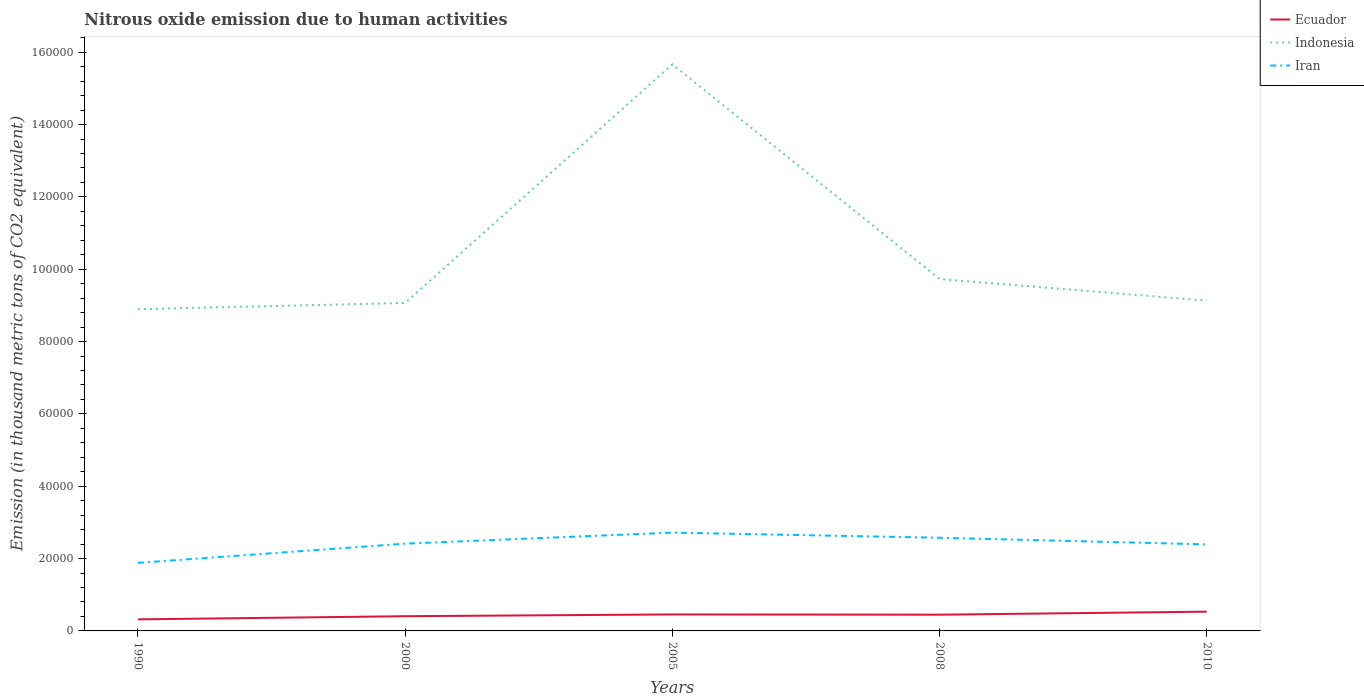How many different coloured lines are there?
Ensure brevity in your answer.  3. Across all years, what is the maximum amount of nitrous oxide emitted in Indonesia?
Your answer should be compact. 8.89e+04. What is the total amount of nitrous oxide emitted in Indonesia in the graph?
Provide a short and direct response. -6610.3. What is the difference between the highest and the second highest amount of nitrous oxide emitted in Ecuador?
Make the answer very short. 2134.1. How many lines are there?
Your answer should be very brief. 3. Does the graph contain grids?
Keep it short and to the point. No. What is the title of the graph?
Give a very brief answer. Nitrous oxide emission due to human activities. What is the label or title of the X-axis?
Offer a very short reply. Years. What is the label or title of the Y-axis?
Offer a terse response. Emission (in thousand metric tons of CO2 equivalent). What is the Emission (in thousand metric tons of CO2 equivalent) of Ecuador in 1990?
Your response must be concise. 3194. What is the Emission (in thousand metric tons of CO2 equivalent) of Indonesia in 1990?
Ensure brevity in your answer.  8.89e+04. What is the Emission (in thousand metric tons of CO2 equivalent) of Iran in 1990?
Provide a succinct answer. 1.88e+04. What is the Emission (in thousand metric tons of CO2 equivalent) of Ecuador in 2000?
Give a very brief answer. 4067.7. What is the Emission (in thousand metric tons of CO2 equivalent) of Indonesia in 2000?
Your answer should be very brief. 9.07e+04. What is the Emission (in thousand metric tons of CO2 equivalent) in Iran in 2000?
Your answer should be very brief. 2.41e+04. What is the Emission (in thousand metric tons of CO2 equivalent) in Ecuador in 2005?
Give a very brief answer. 4558.5. What is the Emission (in thousand metric tons of CO2 equivalent) in Indonesia in 2005?
Make the answer very short. 1.57e+05. What is the Emission (in thousand metric tons of CO2 equivalent) of Iran in 2005?
Offer a very short reply. 2.72e+04. What is the Emission (in thousand metric tons of CO2 equivalent) in Ecuador in 2008?
Give a very brief answer. 4488.1. What is the Emission (in thousand metric tons of CO2 equivalent) of Indonesia in 2008?
Your answer should be compact. 9.73e+04. What is the Emission (in thousand metric tons of CO2 equivalent) in Iran in 2008?
Provide a short and direct response. 2.58e+04. What is the Emission (in thousand metric tons of CO2 equivalent) in Ecuador in 2010?
Offer a terse response. 5328.1. What is the Emission (in thousand metric tons of CO2 equivalent) of Indonesia in 2010?
Ensure brevity in your answer.  9.13e+04. What is the Emission (in thousand metric tons of CO2 equivalent) in Iran in 2010?
Offer a terse response. 2.39e+04. Across all years, what is the maximum Emission (in thousand metric tons of CO2 equivalent) of Ecuador?
Ensure brevity in your answer.  5328.1. Across all years, what is the maximum Emission (in thousand metric tons of CO2 equivalent) of Indonesia?
Provide a succinct answer. 1.57e+05. Across all years, what is the maximum Emission (in thousand metric tons of CO2 equivalent) of Iran?
Offer a terse response. 2.72e+04. Across all years, what is the minimum Emission (in thousand metric tons of CO2 equivalent) of Ecuador?
Ensure brevity in your answer.  3194. Across all years, what is the minimum Emission (in thousand metric tons of CO2 equivalent) in Indonesia?
Keep it short and to the point. 8.89e+04. Across all years, what is the minimum Emission (in thousand metric tons of CO2 equivalent) in Iran?
Make the answer very short. 1.88e+04. What is the total Emission (in thousand metric tons of CO2 equivalent) of Ecuador in the graph?
Give a very brief answer. 2.16e+04. What is the total Emission (in thousand metric tons of CO2 equivalent) of Indonesia in the graph?
Give a very brief answer. 5.25e+05. What is the total Emission (in thousand metric tons of CO2 equivalent) in Iran in the graph?
Keep it short and to the point. 1.20e+05. What is the difference between the Emission (in thousand metric tons of CO2 equivalent) of Ecuador in 1990 and that in 2000?
Keep it short and to the point. -873.7. What is the difference between the Emission (in thousand metric tons of CO2 equivalent) of Indonesia in 1990 and that in 2000?
Give a very brief answer. -1727.1. What is the difference between the Emission (in thousand metric tons of CO2 equivalent) of Iran in 1990 and that in 2000?
Ensure brevity in your answer.  -5303. What is the difference between the Emission (in thousand metric tons of CO2 equivalent) of Ecuador in 1990 and that in 2005?
Give a very brief answer. -1364.5. What is the difference between the Emission (in thousand metric tons of CO2 equivalent) of Indonesia in 1990 and that in 2005?
Your answer should be very brief. -6.77e+04. What is the difference between the Emission (in thousand metric tons of CO2 equivalent) in Iran in 1990 and that in 2005?
Provide a short and direct response. -8355.6. What is the difference between the Emission (in thousand metric tons of CO2 equivalent) in Ecuador in 1990 and that in 2008?
Your response must be concise. -1294.1. What is the difference between the Emission (in thousand metric tons of CO2 equivalent) of Indonesia in 1990 and that in 2008?
Keep it short and to the point. -8337.4. What is the difference between the Emission (in thousand metric tons of CO2 equivalent) of Iran in 1990 and that in 2008?
Provide a short and direct response. -6938.5. What is the difference between the Emission (in thousand metric tons of CO2 equivalent) of Ecuador in 1990 and that in 2010?
Make the answer very short. -2134.1. What is the difference between the Emission (in thousand metric tons of CO2 equivalent) in Indonesia in 1990 and that in 2010?
Give a very brief answer. -2363.1. What is the difference between the Emission (in thousand metric tons of CO2 equivalent) in Iran in 1990 and that in 2010?
Ensure brevity in your answer.  -5102.4. What is the difference between the Emission (in thousand metric tons of CO2 equivalent) in Ecuador in 2000 and that in 2005?
Provide a short and direct response. -490.8. What is the difference between the Emission (in thousand metric tons of CO2 equivalent) of Indonesia in 2000 and that in 2005?
Keep it short and to the point. -6.60e+04. What is the difference between the Emission (in thousand metric tons of CO2 equivalent) in Iran in 2000 and that in 2005?
Offer a very short reply. -3052.6. What is the difference between the Emission (in thousand metric tons of CO2 equivalent) in Ecuador in 2000 and that in 2008?
Offer a terse response. -420.4. What is the difference between the Emission (in thousand metric tons of CO2 equivalent) in Indonesia in 2000 and that in 2008?
Offer a very short reply. -6610.3. What is the difference between the Emission (in thousand metric tons of CO2 equivalent) in Iran in 2000 and that in 2008?
Your answer should be very brief. -1635.5. What is the difference between the Emission (in thousand metric tons of CO2 equivalent) in Ecuador in 2000 and that in 2010?
Ensure brevity in your answer.  -1260.4. What is the difference between the Emission (in thousand metric tons of CO2 equivalent) of Indonesia in 2000 and that in 2010?
Give a very brief answer. -636. What is the difference between the Emission (in thousand metric tons of CO2 equivalent) in Iran in 2000 and that in 2010?
Provide a short and direct response. 200.6. What is the difference between the Emission (in thousand metric tons of CO2 equivalent) of Ecuador in 2005 and that in 2008?
Give a very brief answer. 70.4. What is the difference between the Emission (in thousand metric tons of CO2 equivalent) in Indonesia in 2005 and that in 2008?
Offer a very short reply. 5.94e+04. What is the difference between the Emission (in thousand metric tons of CO2 equivalent) of Iran in 2005 and that in 2008?
Your answer should be very brief. 1417.1. What is the difference between the Emission (in thousand metric tons of CO2 equivalent) of Ecuador in 2005 and that in 2010?
Offer a very short reply. -769.6. What is the difference between the Emission (in thousand metric tons of CO2 equivalent) in Indonesia in 2005 and that in 2010?
Your answer should be compact. 6.53e+04. What is the difference between the Emission (in thousand metric tons of CO2 equivalent) of Iran in 2005 and that in 2010?
Keep it short and to the point. 3253.2. What is the difference between the Emission (in thousand metric tons of CO2 equivalent) in Ecuador in 2008 and that in 2010?
Give a very brief answer. -840. What is the difference between the Emission (in thousand metric tons of CO2 equivalent) of Indonesia in 2008 and that in 2010?
Offer a very short reply. 5974.3. What is the difference between the Emission (in thousand metric tons of CO2 equivalent) in Iran in 2008 and that in 2010?
Provide a succinct answer. 1836.1. What is the difference between the Emission (in thousand metric tons of CO2 equivalent) of Ecuador in 1990 and the Emission (in thousand metric tons of CO2 equivalent) of Indonesia in 2000?
Offer a terse response. -8.75e+04. What is the difference between the Emission (in thousand metric tons of CO2 equivalent) of Ecuador in 1990 and the Emission (in thousand metric tons of CO2 equivalent) of Iran in 2000?
Ensure brevity in your answer.  -2.09e+04. What is the difference between the Emission (in thousand metric tons of CO2 equivalent) in Indonesia in 1990 and the Emission (in thousand metric tons of CO2 equivalent) in Iran in 2000?
Ensure brevity in your answer.  6.48e+04. What is the difference between the Emission (in thousand metric tons of CO2 equivalent) of Ecuador in 1990 and the Emission (in thousand metric tons of CO2 equivalent) of Indonesia in 2005?
Your response must be concise. -1.53e+05. What is the difference between the Emission (in thousand metric tons of CO2 equivalent) of Ecuador in 1990 and the Emission (in thousand metric tons of CO2 equivalent) of Iran in 2005?
Ensure brevity in your answer.  -2.40e+04. What is the difference between the Emission (in thousand metric tons of CO2 equivalent) of Indonesia in 1990 and the Emission (in thousand metric tons of CO2 equivalent) of Iran in 2005?
Give a very brief answer. 6.18e+04. What is the difference between the Emission (in thousand metric tons of CO2 equivalent) of Ecuador in 1990 and the Emission (in thousand metric tons of CO2 equivalent) of Indonesia in 2008?
Ensure brevity in your answer.  -9.41e+04. What is the difference between the Emission (in thousand metric tons of CO2 equivalent) in Ecuador in 1990 and the Emission (in thousand metric tons of CO2 equivalent) in Iran in 2008?
Offer a terse response. -2.26e+04. What is the difference between the Emission (in thousand metric tons of CO2 equivalent) in Indonesia in 1990 and the Emission (in thousand metric tons of CO2 equivalent) in Iran in 2008?
Provide a succinct answer. 6.32e+04. What is the difference between the Emission (in thousand metric tons of CO2 equivalent) of Ecuador in 1990 and the Emission (in thousand metric tons of CO2 equivalent) of Indonesia in 2010?
Ensure brevity in your answer.  -8.81e+04. What is the difference between the Emission (in thousand metric tons of CO2 equivalent) in Ecuador in 1990 and the Emission (in thousand metric tons of CO2 equivalent) in Iran in 2010?
Keep it short and to the point. -2.07e+04. What is the difference between the Emission (in thousand metric tons of CO2 equivalent) of Indonesia in 1990 and the Emission (in thousand metric tons of CO2 equivalent) of Iran in 2010?
Your answer should be compact. 6.50e+04. What is the difference between the Emission (in thousand metric tons of CO2 equivalent) in Ecuador in 2000 and the Emission (in thousand metric tons of CO2 equivalent) in Indonesia in 2005?
Give a very brief answer. -1.53e+05. What is the difference between the Emission (in thousand metric tons of CO2 equivalent) of Ecuador in 2000 and the Emission (in thousand metric tons of CO2 equivalent) of Iran in 2005?
Keep it short and to the point. -2.31e+04. What is the difference between the Emission (in thousand metric tons of CO2 equivalent) in Indonesia in 2000 and the Emission (in thousand metric tons of CO2 equivalent) in Iran in 2005?
Offer a terse response. 6.35e+04. What is the difference between the Emission (in thousand metric tons of CO2 equivalent) in Ecuador in 2000 and the Emission (in thousand metric tons of CO2 equivalent) in Indonesia in 2008?
Your answer should be very brief. -9.32e+04. What is the difference between the Emission (in thousand metric tons of CO2 equivalent) of Ecuador in 2000 and the Emission (in thousand metric tons of CO2 equivalent) of Iran in 2008?
Ensure brevity in your answer.  -2.17e+04. What is the difference between the Emission (in thousand metric tons of CO2 equivalent) of Indonesia in 2000 and the Emission (in thousand metric tons of CO2 equivalent) of Iran in 2008?
Provide a succinct answer. 6.49e+04. What is the difference between the Emission (in thousand metric tons of CO2 equivalent) in Ecuador in 2000 and the Emission (in thousand metric tons of CO2 equivalent) in Indonesia in 2010?
Offer a very short reply. -8.72e+04. What is the difference between the Emission (in thousand metric tons of CO2 equivalent) of Ecuador in 2000 and the Emission (in thousand metric tons of CO2 equivalent) of Iran in 2010?
Offer a terse response. -1.99e+04. What is the difference between the Emission (in thousand metric tons of CO2 equivalent) in Indonesia in 2000 and the Emission (in thousand metric tons of CO2 equivalent) in Iran in 2010?
Make the answer very short. 6.67e+04. What is the difference between the Emission (in thousand metric tons of CO2 equivalent) of Ecuador in 2005 and the Emission (in thousand metric tons of CO2 equivalent) of Indonesia in 2008?
Keep it short and to the point. -9.27e+04. What is the difference between the Emission (in thousand metric tons of CO2 equivalent) of Ecuador in 2005 and the Emission (in thousand metric tons of CO2 equivalent) of Iran in 2008?
Give a very brief answer. -2.12e+04. What is the difference between the Emission (in thousand metric tons of CO2 equivalent) in Indonesia in 2005 and the Emission (in thousand metric tons of CO2 equivalent) in Iran in 2008?
Your answer should be very brief. 1.31e+05. What is the difference between the Emission (in thousand metric tons of CO2 equivalent) in Ecuador in 2005 and the Emission (in thousand metric tons of CO2 equivalent) in Indonesia in 2010?
Offer a terse response. -8.68e+04. What is the difference between the Emission (in thousand metric tons of CO2 equivalent) of Ecuador in 2005 and the Emission (in thousand metric tons of CO2 equivalent) of Iran in 2010?
Provide a short and direct response. -1.94e+04. What is the difference between the Emission (in thousand metric tons of CO2 equivalent) in Indonesia in 2005 and the Emission (in thousand metric tons of CO2 equivalent) in Iran in 2010?
Make the answer very short. 1.33e+05. What is the difference between the Emission (in thousand metric tons of CO2 equivalent) in Ecuador in 2008 and the Emission (in thousand metric tons of CO2 equivalent) in Indonesia in 2010?
Keep it short and to the point. -8.68e+04. What is the difference between the Emission (in thousand metric tons of CO2 equivalent) of Ecuador in 2008 and the Emission (in thousand metric tons of CO2 equivalent) of Iran in 2010?
Give a very brief answer. -1.94e+04. What is the difference between the Emission (in thousand metric tons of CO2 equivalent) in Indonesia in 2008 and the Emission (in thousand metric tons of CO2 equivalent) in Iran in 2010?
Make the answer very short. 7.34e+04. What is the average Emission (in thousand metric tons of CO2 equivalent) of Ecuador per year?
Keep it short and to the point. 4327.28. What is the average Emission (in thousand metric tons of CO2 equivalent) in Indonesia per year?
Offer a terse response. 1.05e+05. What is the average Emission (in thousand metric tons of CO2 equivalent) of Iran per year?
Your answer should be compact. 2.40e+04. In the year 1990, what is the difference between the Emission (in thousand metric tons of CO2 equivalent) in Ecuador and Emission (in thousand metric tons of CO2 equivalent) in Indonesia?
Give a very brief answer. -8.58e+04. In the year 1990, what is the difference between the Emission (in thousand metric tons of CO2 equivalent) in Ecuador and Emission (in thousand metric tons of CO2 equivalent) in Iran?
Ensure brevity in your answer.  -1.56e+04. In the year 1990, what is the difference between the Emission (in thousand metric tons of CO2 equivalent) of Indonesia and Emission (in thousand metric tons of CO2 equivalent) of Iran?
Ensure brevity in your answer.  7.01e+04. In the year 2000, what is the difference between the Emission (in thousand metric tons of CO2 equivalent) of Ecuador and Emission (in thousand metric tons of CO2 equivalent) of Indonesia?
Your answer should be very brief. -8.66e+04. In the year 2000, what is the difference between the Emission (in thousand metric tons of CO2 equivalent) of Ecuador and Emission (in thousand metric tons of CO2 equivalent) of Iran?
Provide a short and direct response. -2.01e+04. In the year 2000, what is the difference between the Emission (in thousand metric tons of CO2 equivalent) of Indonesia and Emission (in thousand metric tons of CO2 equivalent) of Iran?
Provide a succinct answer. 6.65e+04. In the year 2005, what is the difference between the Emission (in thousand metric tons of CO2 equivalent) of Ecuador and Emission (in thousand metric tons of CO2 equivalent) of Indonesia?
Offer a very short reply. -1.52e+05. In the year 2005, what is the difference between the Emission (in thousand metric tons of CO2 equivalent) of Ecuador and Emission (in thousand metric tons of CO2 equivalent) of Iran?
Your answer should be compact. -2.26e+04. In the year 2005, what is the difference between the Emission (in thousand metric tons of CO2 equivalent) of Indonesia and Emission (in thousand metric tons of CO2 equivalent) of Iran?
Your answer should be very brief. 1.29e+05. In the year 2008, what is the difference between the Emission (in thousand metric tons of CO2 equivalent) of Ecuador and Emission (in thousand metric tons of CO2 equivalent) of Indonesia?
Provide a short and direct response. -9.28e+04. In the year 2008, what is the difference between the Emission (in thousand metric tons of CO2 equivalent) of Ecuador and Emission (in thousand metric tons of CO2 equivalent) of Iran?
Your response must be concise. -2.13e+04. In the year 2008, what is the difference between the Emission (in thousand metric tons of CO2 equivalent) of Indonesia and Emission (in thousand metric tons of CO2 equivalent) of Iran?
Your answer should be compact. 7.15e+04. In the year 2010, what is the difference between the Emission (in thousand metric tons of CO2 equivalent) of Ecuador and Emission (in thousand metric tons of CO2 equivalent) of Indonesia?
Your answer should be very brief. -8.60e+04. In the year 2010, what is the difference between the Emission (in thousand metric tons of CO2 equivalent) of Ecuador and Emission (in thousand metric tons of CO2 equivalent) of Iran?
Provide a succinct answer. -1.86e+04. In the year 2010, what is the difference between the Emission (in thousand metric tons of CO2 equivalent) in Indonesia and Emission (in thousand metric tons of CO2 equivalent) in Iran?
Offer a terse response. 6.74e+04. What is the ratio of the Emission (in thousand metric tons of CO2 equivalent) in Ecuador in 1990 to that in 2000?
Ensure brevity in your answer.  0.79. What is the ratio of the Emission (in thousand metric tons of CO2 equivalent) of Indonesia in 1990 to that in 2000?
Provide a short and direct response. 0.98. What is the ratio of the Emission (in thousand metric tons of CO2 equivalent) in Iran in 1990 to that in 2000?
Make the answer very short. 0.78. What is the ratio of the Emission (in thousand metric tons of CO2 equivalent) of Ecuador in 1990 to that in 2005?
Offer a very short reply. 0.7. What is the ratio of the Emission (in thousand metric tons of CO2 equivalent) in Indonesia in 1990 to that in 2005?
Make the answer very short. 0.57. What is the ratio of the Emission (in thousand metric tons of CO2 equivalent) of Iran in 1990 to that in 2005?
Your answer should be very brief. 0.69. What is the ratio of the Emission (in thousand metric tons of CO2 equivalent) in Ecuador in 1990 to that in 2008?
Offer a very short reply. 0.71. What is the ratio of the Emission (in thousand metric tons of CO2 equivalent) of Indonesia in 1990 to that in 2008?
Your response must be concise. 0.91. What is the ratio of the Emission (in thousand metric tons of CO2 equivalent) of Iran in 1990 to that in 2008?
Give a very brief answer. 0.73. What is the ratio of the Emission (in thousand metric tons of CO2 equivalent) of Ecuador in 1990 to that in 2010?
Ensure brevity in your answer.  0.6. What is the ratio of the Emission (in thousand metric tons of CO2 equivalent) of Indonesia in 1990 to that in 2010?
Provide a succinct answer. 0.97. What is the ratio of the Emission (in thousand metric tons of CO2 equivalent) of Iran in 1990 to that in 2010?
Keep it short and to the point. 0.79. What is the ratio of the Emission (in thousand metric tons of CO2 equivalent) of Ecuador in 2000 to that in 2005?
Provide a short and direct response. 0.89. What is the ratio of the Emission (in thousand metric tons of CO2 equivalent) of Indonesia in 2000 to that in 2005?
Provide a succinct answer. 0.58. What is the ratio of the Emission (in thousand metric tons of CO2 equivalent) of Iran in 2000 to that in 2005?
Your answer should be compact. 0.89. What is the ratio of the Emission (in thousand metric tons of CO2 equivalent) of Ecuador in 2000 to that in 2008?
Keep it short and to the point. 0.91. What is the ratio of the Emission (in thousand metric tons of CO2 equivalent) in Indonesia in 2000 to that in 2008?
Provide a short and direct response. 0.93. What is the ratio of the Emission (in thousand metric tons of CO2 equivalent) in Iran in 2000 to that in 2008?
Offer a terse response. 0.94. What is the ratio of the Emission (in thousand metric tons of CO2 equivalent) in Ecuador in 2000 to that in 2010?
Provide a succinct answer. 0.76. What is the ratio of the Emission (in thousand metric tons of CO2 equivalent) in Indonesia in 2000 to that in 2010?
Give a very brief answer. 0.99. What is the ratio of the Emission (in thousand metric tons of CO2 equivalent) in Iran in 2000 to that in 2010?
Offer a terse response. 1.01. What is the ratio of the Emission (in thousand metric tons of CO2 equivalent) in Ecuador in 2005 to that in 2008?
Make the answer very short. 1.02. What is the ratio of the Emission (in thousand metric tons of CO2 equivalent) in Indonesia in 2005 to that in 2008?
Provide a succinct answer. 1.61. What is the ratio of the Emission (in thousand metric tons of CO2 equivalent) in Iran in 2005 to that in 2008?
Provide a succinct answer. 1.05. What is the ratio of the Emission (in thousand metric tons of CO2 equivalent) in Ecuador in 2005 to that in 2010?
Your answer should be very brief. 0.86. What is the ratio of the Emission (in thousand metric tons of CO2 equivalent) in Indonesia in 2005 to that in 2010?
Make the answer very short. 1.72. What is the ratio of the Emission (in thousand metric tons of CO2 equivalent) in Iran in 2005 to that in 2010?
Provide a succinct answer. 1.14. What is the ratio of the Emission (in thousand metric tons of CO2 equivalent) in Ecuador in 2008 to that in 2010?
Offer a very short reply. 0.84. What is the ratio of the Emission (in thousand metric tons of CO2 equivalent) in Indonesia in 2008 to that in 2010?
Your answer should be very brief. 1.07. What is the ratio of the Emission (in thousand metric tons of CO2 equivalent) of Iran in 2008 to that in 2010?
Your answer should be compact. 1.08. What is the difference between the highest and the second highest Emission (in thousand metric tons of CO2 equivalent) in Ecuador?
Offer a very short reply. 769.6. What is the difference between the highest and the second highest Emission (in thousand metric tons of CO2 equivalent) in Indonesia?
Make the answer very short. 5.94e+04. What is the difference between the highest and the second highest Emission (in thousand metric tons of CO2 equivalent) in Iran?
Provide a succinct answer. 1417.1. What is the difference between the highest and the lowest Emission (in thousand metric tons of CO2 equivalent) in Ecuador?
Provide a succinct answer. 2134.1. What is the difference between the highest and the lowest Emission (in thousand metric tons of CO2 equivalent) of Indonesia?
Provide a succinct answer. 6.77e+04. What is the difference between the highest and the lowest Emission (in thousand metric tons of CO2 equivalent) in Iran?
Provide a succinct answer. 8355.6. 